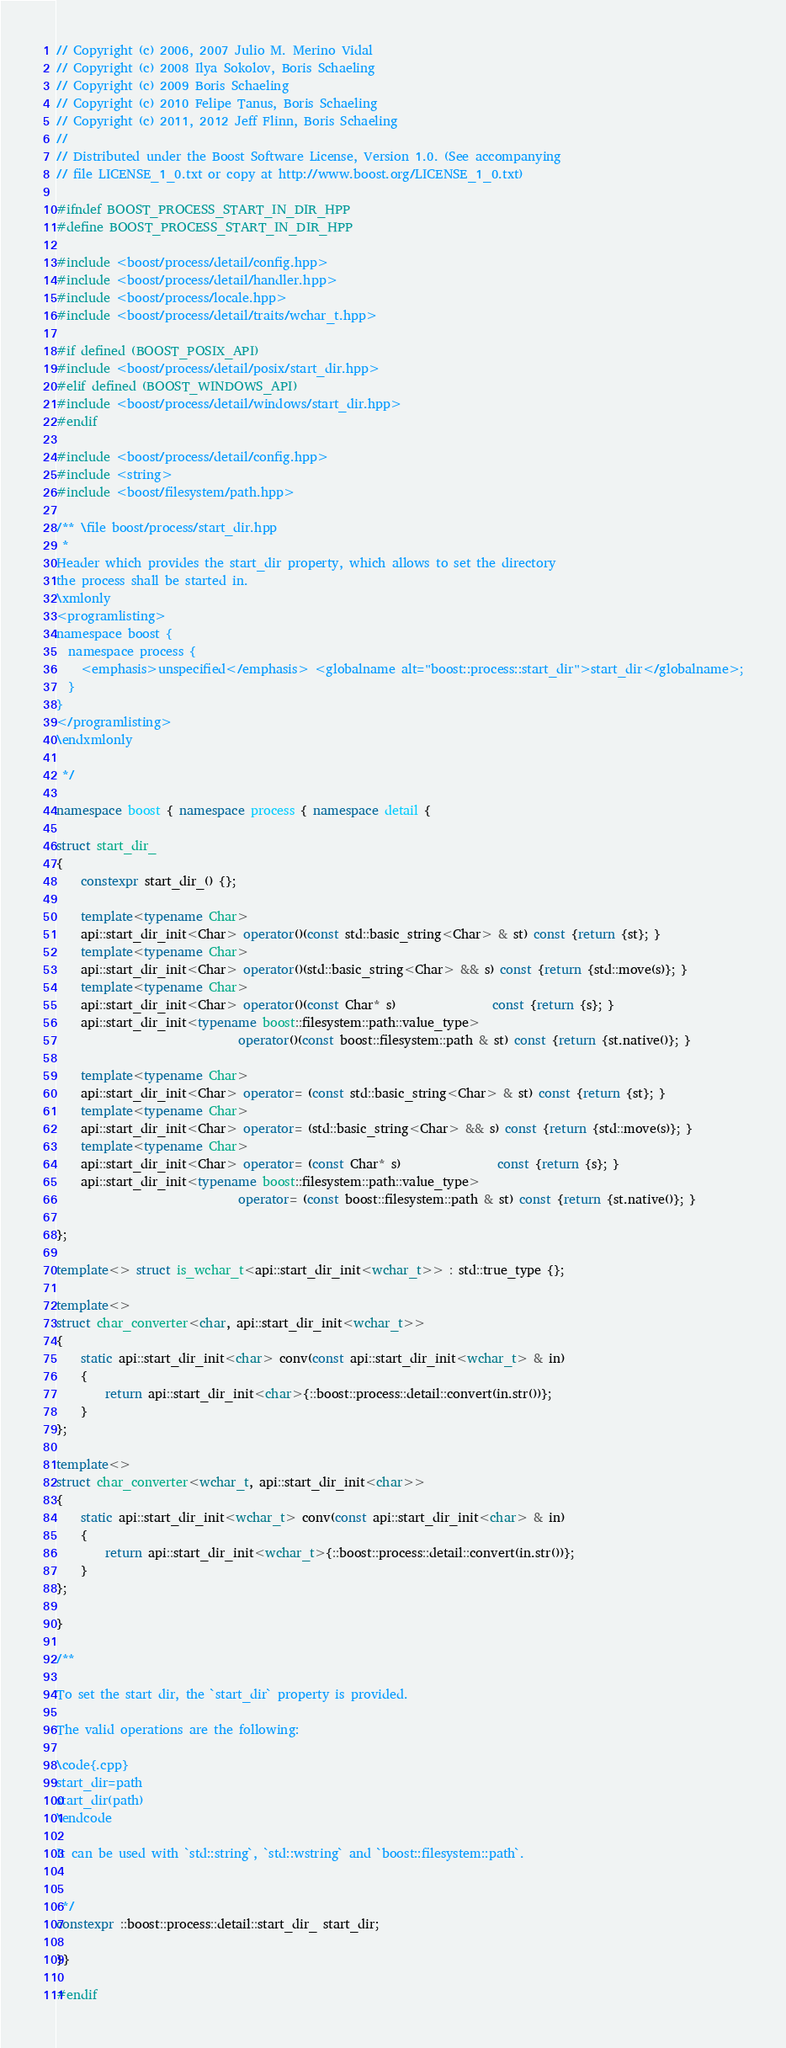<code> <loc_0><loc_0><loc_500><loc_500><_C++_>// Copyright (c) 2006, 2007 Julio M. Merino Vidal
// Copyright (c) 2008 Ilya Sokolov, Boris Schaeling
// Copyright (c) 2009 Boris Schaeling
// Copyright (c) 2010 Felipe Tanus, Boris Schaeling
// Copyright (c) 2011, 2012 Jeff Flinn, Boris Schaeling
//
// Distributed under the Boost Software License, Version 1.0. (See accompanying
// file LICENSE_1_0.txt or copy at http://www.boost.org/LICENSE_1_0.txt)

#ifndef BOOST_PROCESS_START_IN_DIR_HPP
#define BOOST_PROCESS_START_IN_DIR_HPP

#include <boost/process/detail/config.hpp>
#include <boost/process/detail/handler.hpp>
#include <boost/process/locale.hpp>
#include <boost/process/detail/traits/wchar_t.hpp>

#if defined (BOOST_POSIX_API)
#include <boost/process/detail/posix/start_dir.hpp>
#elif defined (BOOST_WINDOWS_API)
#include <boost/process/detail/windows/start_dir.hpp>
#endif

#include <boost/process/detail/config.hpp>
#include <string>
#include <boost/filesystem/path.hpp>

/** \file boost/process/start_dir.hpp
 *
Header which provides the start_dir property, which allows to set the directory
the process shall be started in.
\xmlonly
<programlisting>
namespace boost {
  namespace process {
    <emphasis>unspecified</emphasis> <globalname alt="boost::process::start_dir">start_dir</globalname>;
  }
}
</programlisting>
\endxmlonly

 */

namespace boost { namespace process { namespace detail {

struct start_dir_
{
    constexpr start_dir_() {};

    template<typename Char>
    api::start_dir_init<Char> operator()(const std::basic_string<Char> & st) const {return {st}; }
    template<typename Char>
    api::start_dir_init<Char> operator()(std::basic_string<Char> && s) const {return {std::move(s)}; }
    template<typename Char>
    api::start_dir_init<Char> operator()(const Char* s)                const {return {s}; }
    api::start_dir_init<typename boost::filesystem::path::value_type>
                              operator()(const boost::filesystem::path & st) const {return {st.native()}; }

    template<typename Char>
    api::start_dir_init<Char> operator= (const std::basic_string<Char> & st) const {return {st}; }
    template<typename Char>
    api::start_dir_init<Char> operator= (std::basic_string<Char> && s) const {return {std::move(s)}; }
    template<typename Char>
    api::start_dir_init<Char> operator= (const Char* s)                const {return {s}; }
    api::start_dir_init<typename boost::filesystem::path::value_type>
                              operator= (const boost::filesystem::path & st) const {return {st.native()}; }

};

template<> struct is_wchar_t<api::start_dir_init<wchar_t>> : std::true_type {};

template<>
struct char_converter<char, api::start_dir_init<wchar_t>>
{
    static api::start_dir_init<char> conv(const api::start_dir_init<wchar_t> & in)
    {
        return api::start_dir_init<char>{::boost::process::detail::convert(in.str())};
    }
};

template<>
struct char_converter<wchar_t, api::start_dir_init<char>>
{
    static api::start_dir_init<wchar_t> conv(const api::start_dir_init<char> & in)
    {
        return api::start_dir_init<wchar_t>{::boost::process::detail::convert(in.str())};
    }
};

}

/**

To set the start dir, the `start_dir` property is provided.

The valid operations are the following:

\code{.cpp}
start_dir=path
start_dir(path)
\endcode

It can be used with `std::string`, `std::wstring` and `boost::filesystem::path`.


 */
constexpr ::boost::process::detail::start_dir_ start_dir;

}}

#endif
</code> 